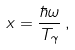<formula> <loc_0><loc_0><loc_500><loc_500>x = \frac { \hbar { \omega } } { T _ { \gamma } } \, ,</formula> 